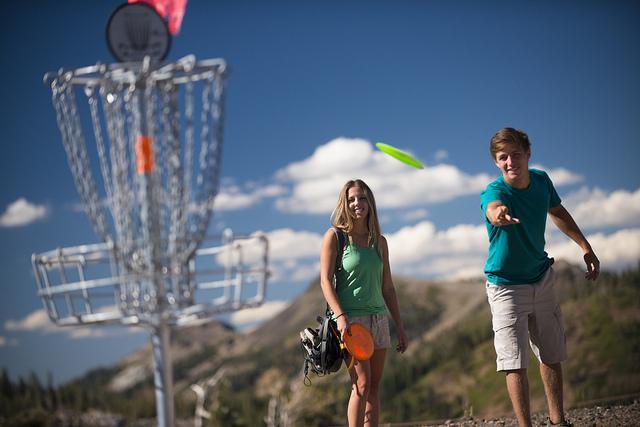Considering their attire, what is the temperature like?
Be succinct. Warm. What color is the frisbee the woman is holding?
Quick response, please. Orange. What game are they playing?
Give a very brief answer. Frisbee. 